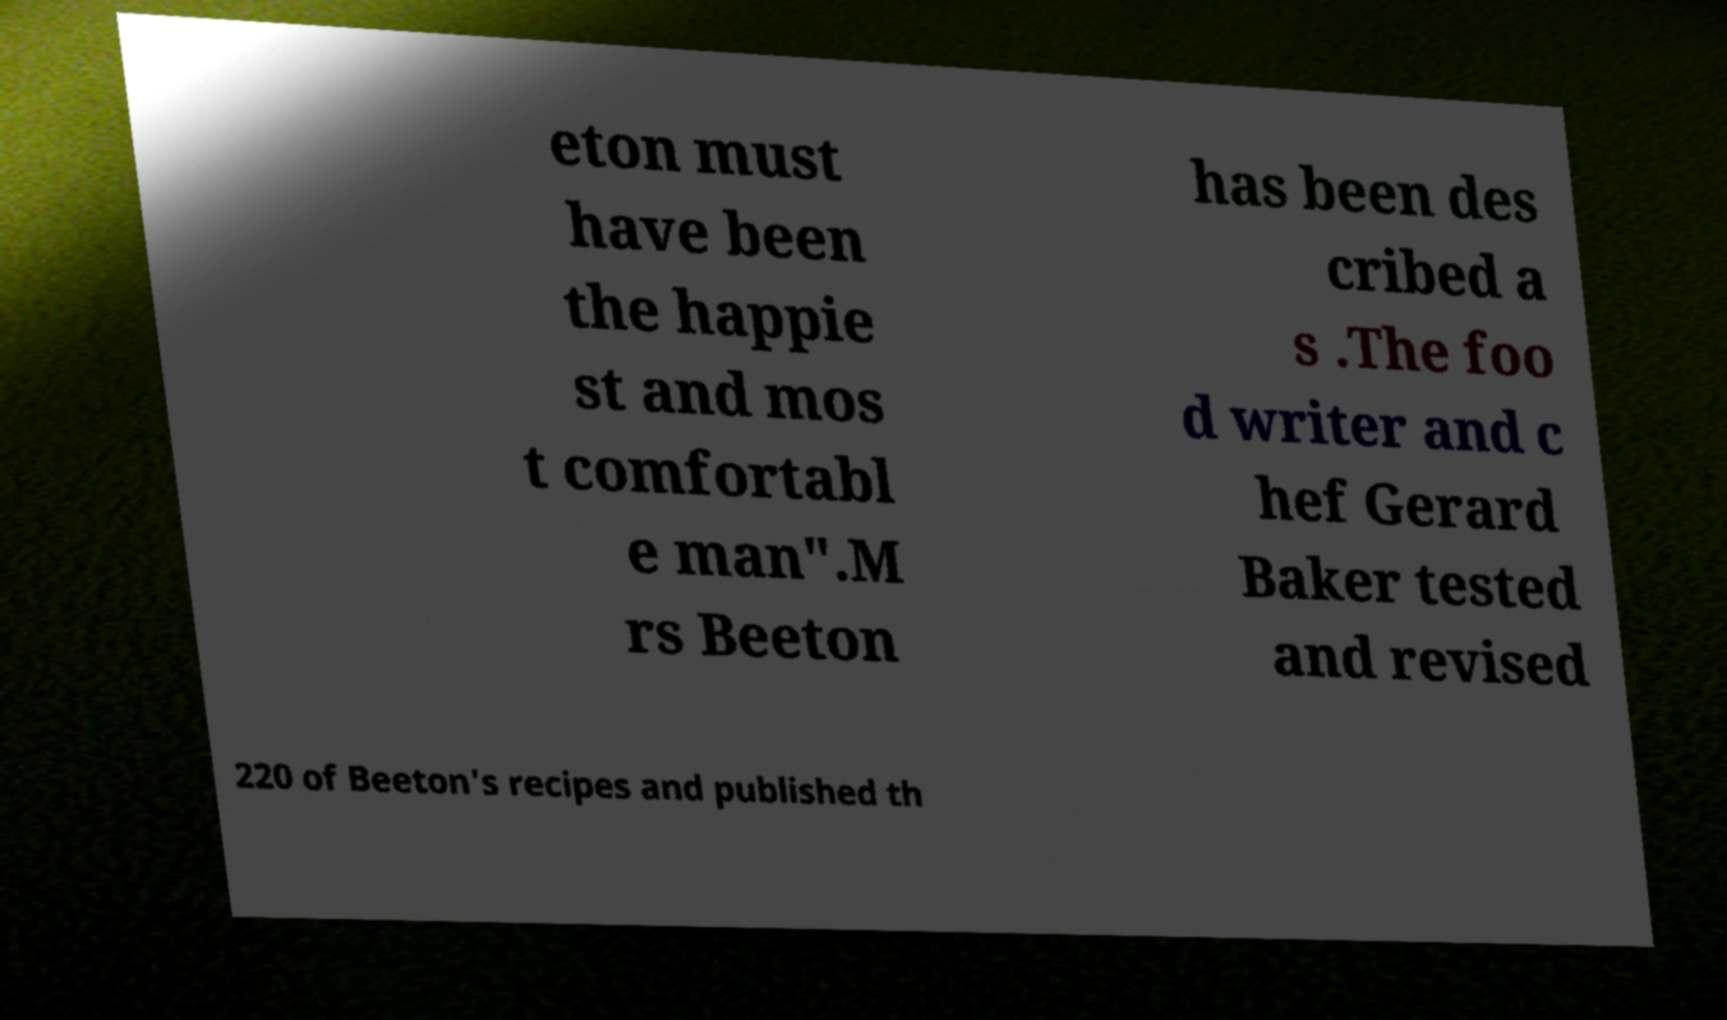Please identify and transcribe the text found in this image. eton must have been the happie st and mos t comfortabl e man".M rs Beeton has been des cribed a s .The foo d writer and c hef Gerard Baker tested and revised 220 of Beeton's recipes and published th 